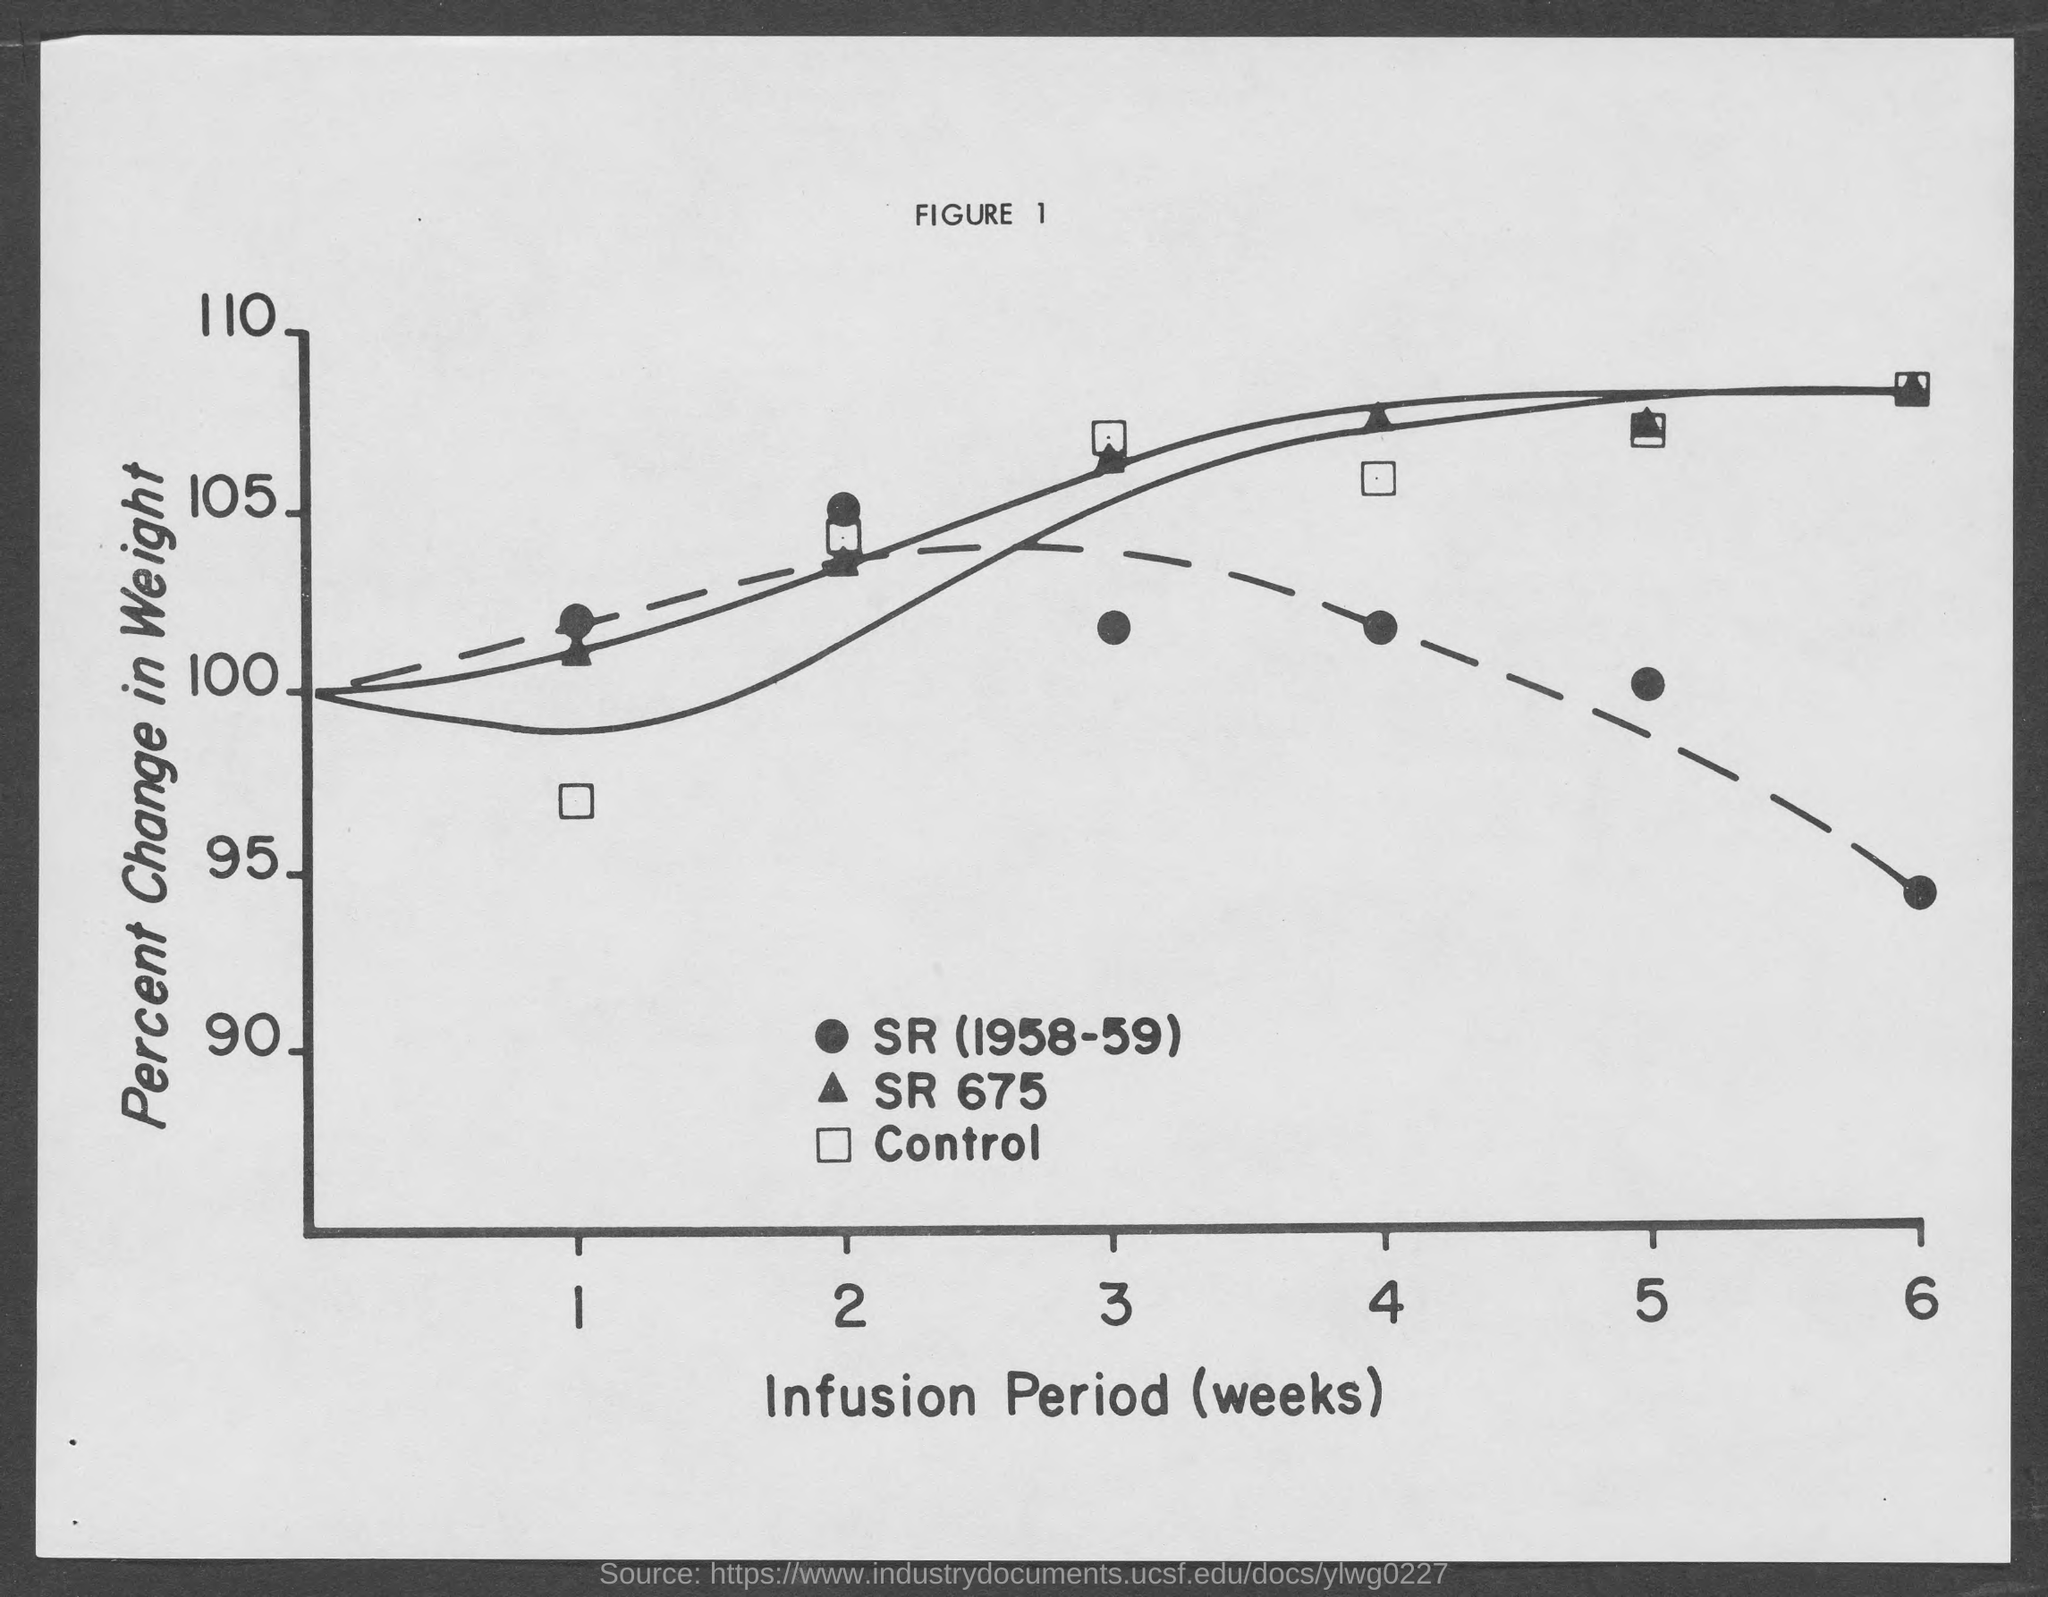Indicate a few pertinent items in this graphic. What is the figure number? The figure consists of numbers 1 through 10. The Y-axis represents the percentage change in weight. 